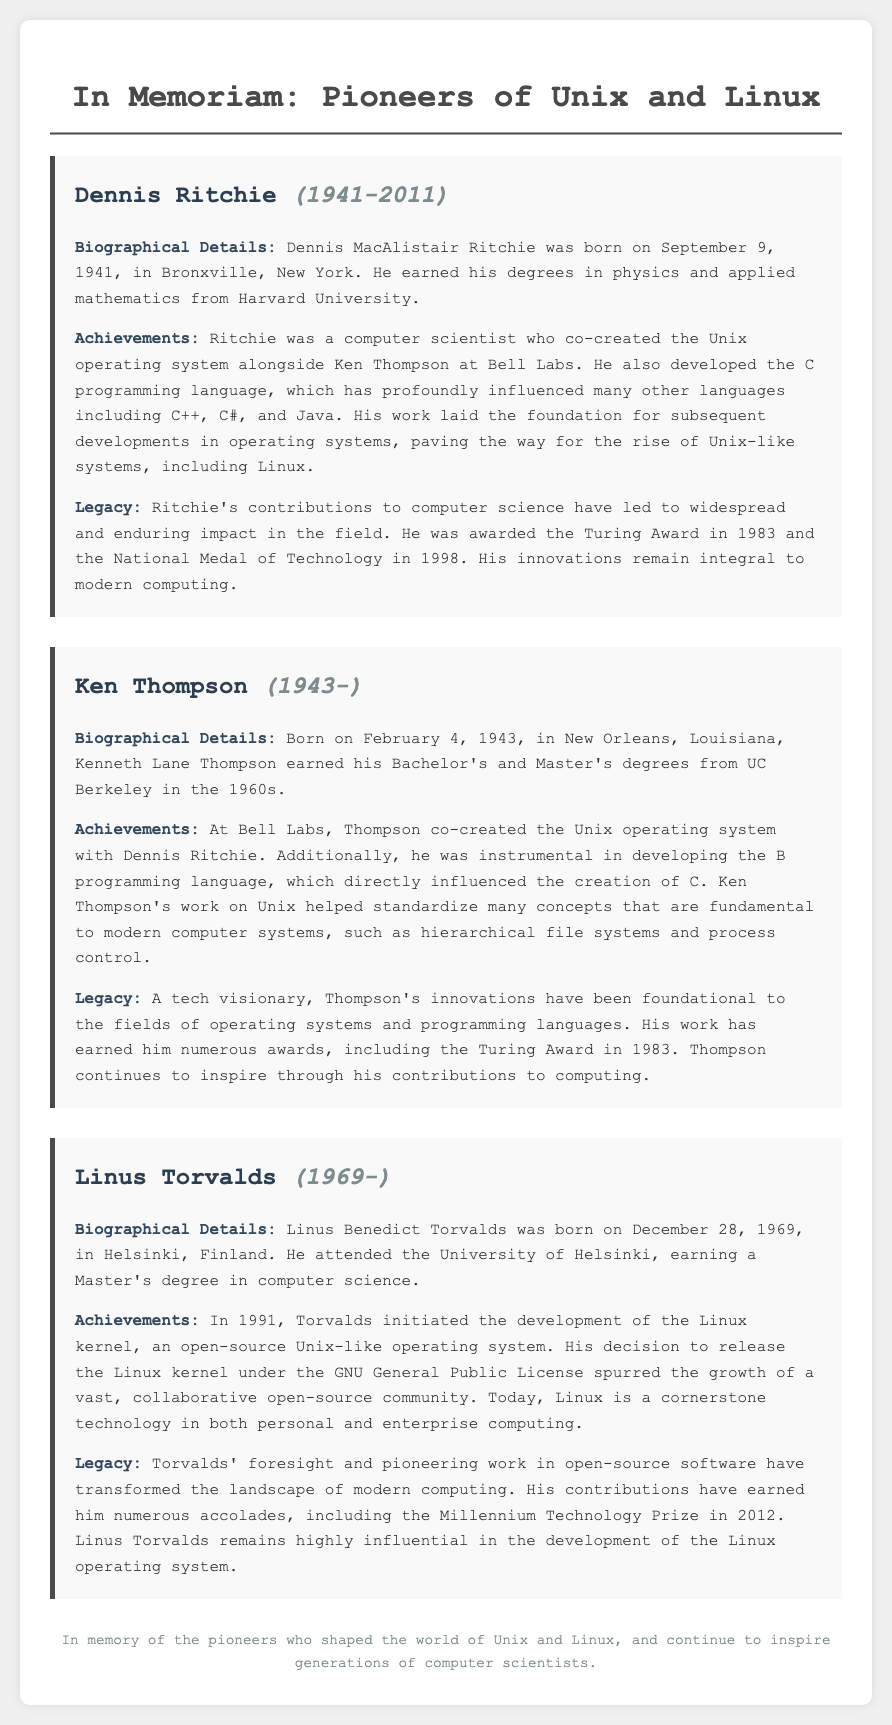What year was Dennis Ritchie born? The document states that Dennis Ritchie was born on September 9, 1941.
Answer: 1941 What programming language did Dennis Ritchie develop? The document mentions that Dennis Ritchie developed the C programming language.
Answer: C Who co-created the Unix operating system with Dennis Ritchie? The document states that Ken Thompson co-created the Unix operating system with Dennis Ritchie.
Answer: Ken Thompson What notable award did Ken Thompson receive in 1983? The document indicates that Ken Thompson received the Turing Award in 1983.
Answer: Turing Award In what year did Linus Torvalds initiate the Linux kernel development? According to the document, Linus Torvalds initiated the development of the Linux kernel in 1991.
Answer: 1991 What is the main impact of Linus Torvalds' decision to release the Linux kernel? The document explains that his decision spurred the growth of a vast, collaborative open-source community.
Answer: Open-source community What university did Linus Torvalds attend? The document states that Linus Torvalds attended the University of Helsinki.
Answer: University of Helsinki What did Dennis Ritchie co-create alongside Unix? The document notes that he co-created the C programming language alongside Unix.
Answer: C programming language What is the theme of the document? The document is focused on memorializing key figures in the development of Unix and its transition to Linux.
Answer: Memorializing key figures 